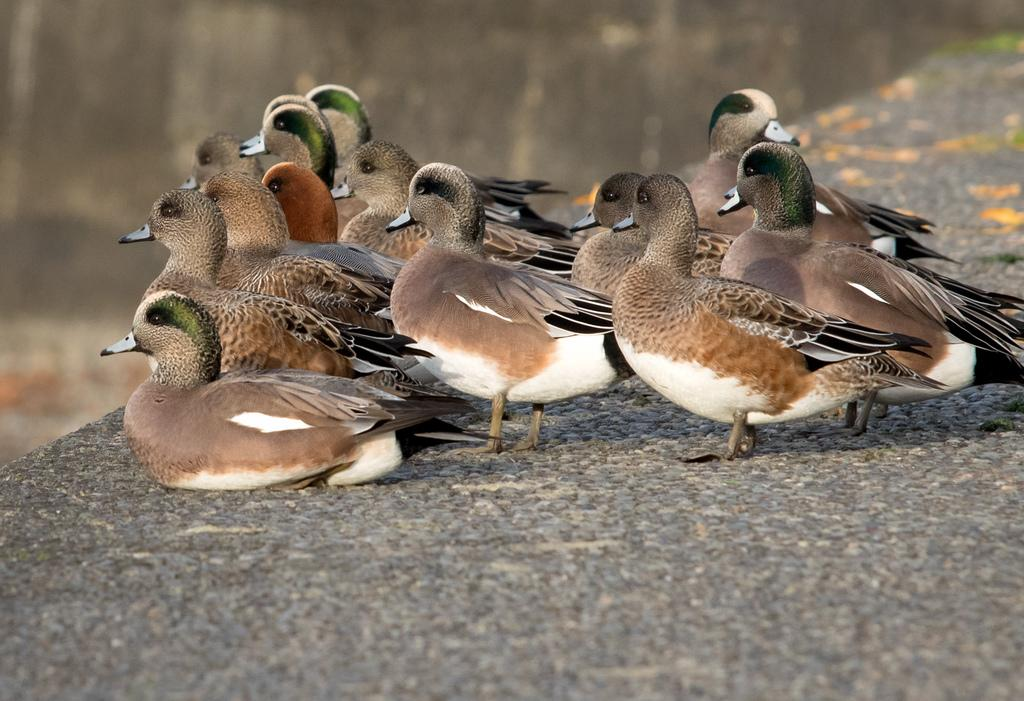What is the main subject of the image? The main subject of the image is many birds. Where are the birds located in the image? The birds are on a wall in the image. What color are the birds in the image? The birds are in brown color. Can you describe the background of the image? The background of the image is blurred. How many books are being held by the birds in the image? There are no books present in the image; it features many birds on a wall. What type of competition are the birds participating in within the image? There is no competition depicted in the image; it simply shows birds on a wall. 